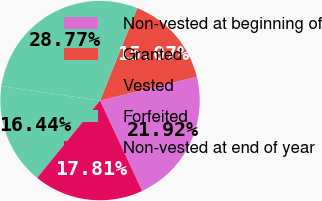Convert chart. <chart><loc_0><loc_0><loc_500><loc_500><pie_chart><fcel>Non-vested at beginning of<fcel>Granted<fcel>Vested<fcel>Forfeited<fcel>Non-vested at end of year<nl><fcel>21.92%<fcel>15.07%<fcel>28.77%<fcel>16.44%<fcel>17.81%<nl></chart> 